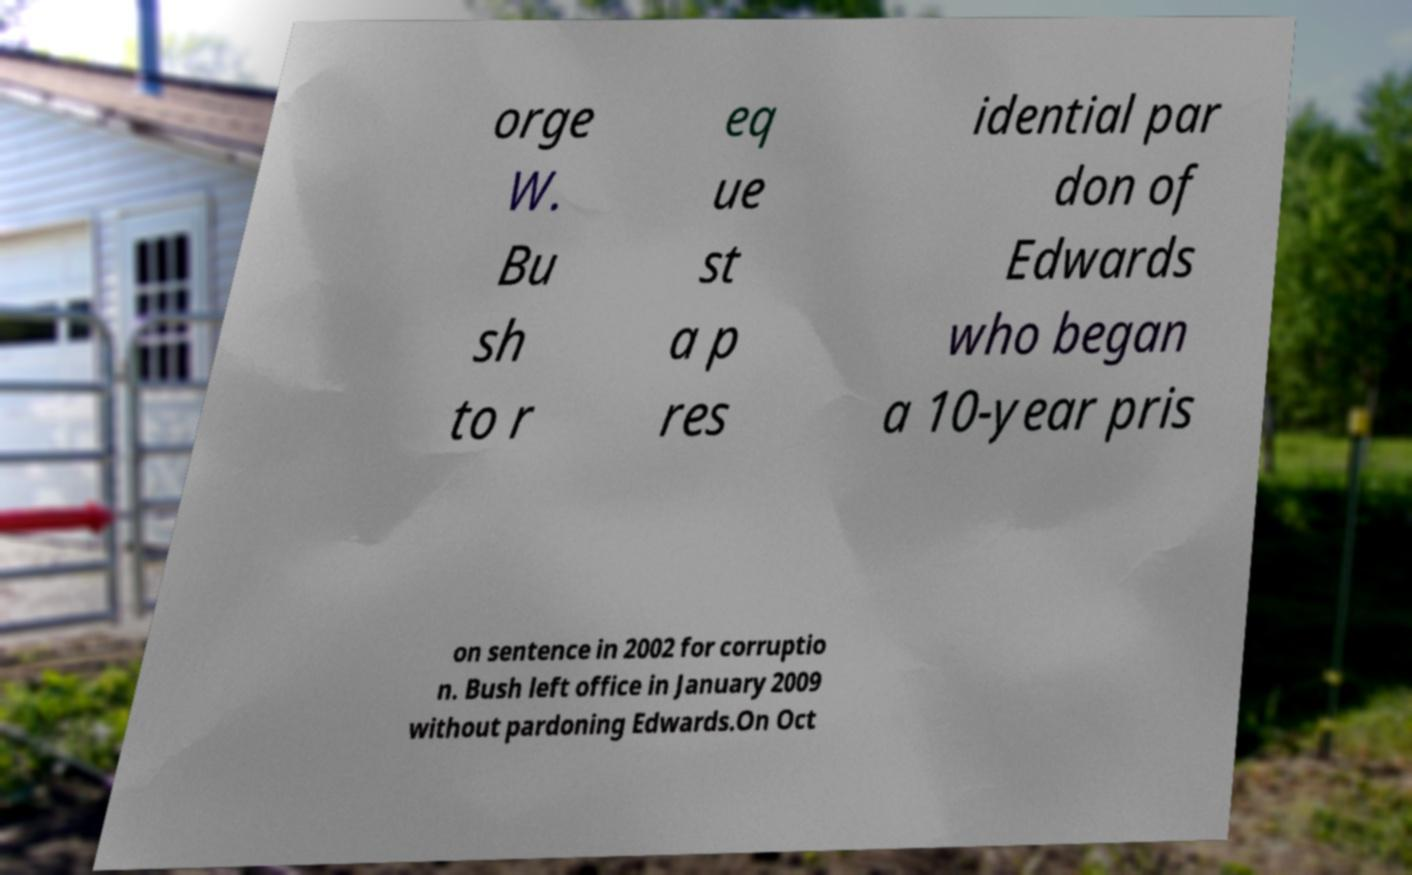Please read and relay the text visible in this image. What does it say? orge W. Bu sh to r eq ue st a p res idential par don of Edwards who began a 10-year pris on sentence in 2002 for corruptio n. Bush left office in January 2009 without pardoning Edwards.On Oct 